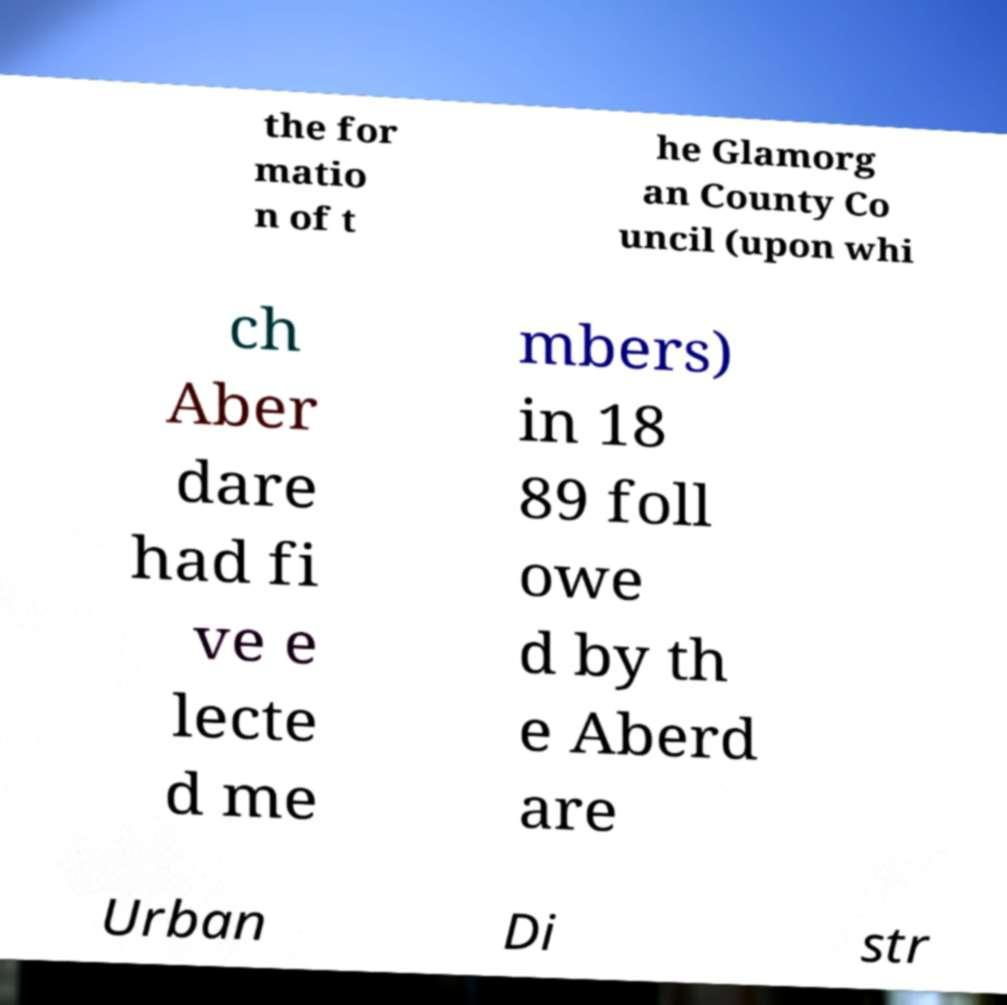Could you extract and type out the text from this image? the for matio n of t he Glamorg an County Co uncil (upon whi ch Aber dare had fi ve e lecte d me mbers) in 18 89 foll owe d by th e Aberd are Urban Di str 